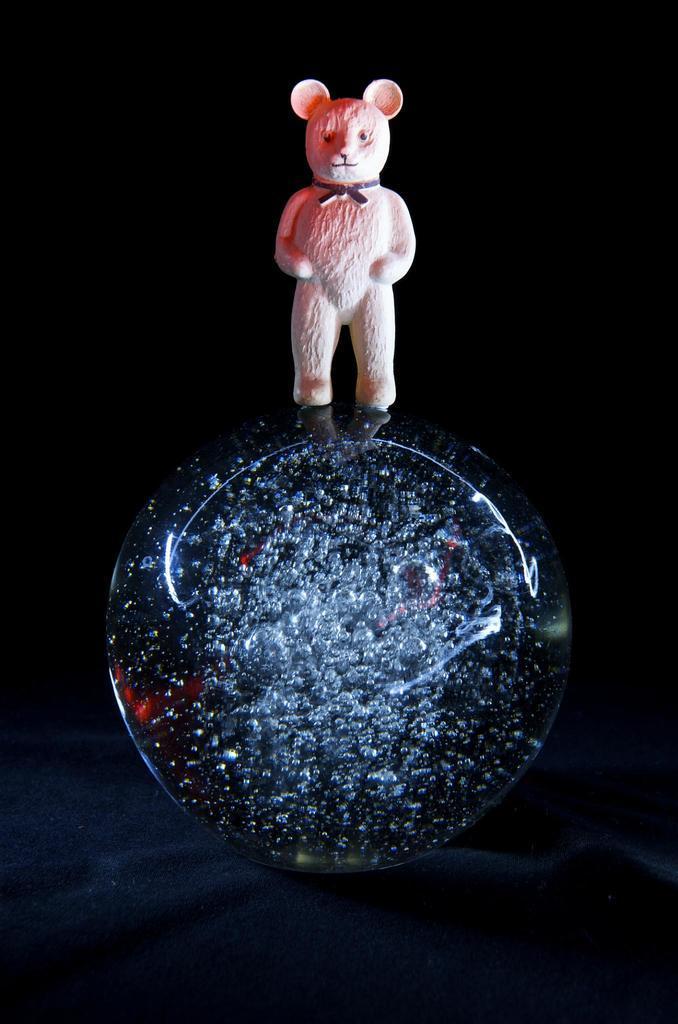Describe this image in one or two sentences. In the center of the image there is a doll on the crystal. 